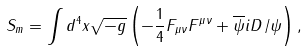<formula> <loc_0><loc_0><loc_500><loc_500>S _ { m } = \int d ^ { 4 } x \sqrt { - g } \left ( - \frac { 1 } { 4 } F _ { \mu \nu } F ^ { \mu \nu } + \overline { \psi } i D \mathcal { \, } \slash \psi \right ) ,</formula> 